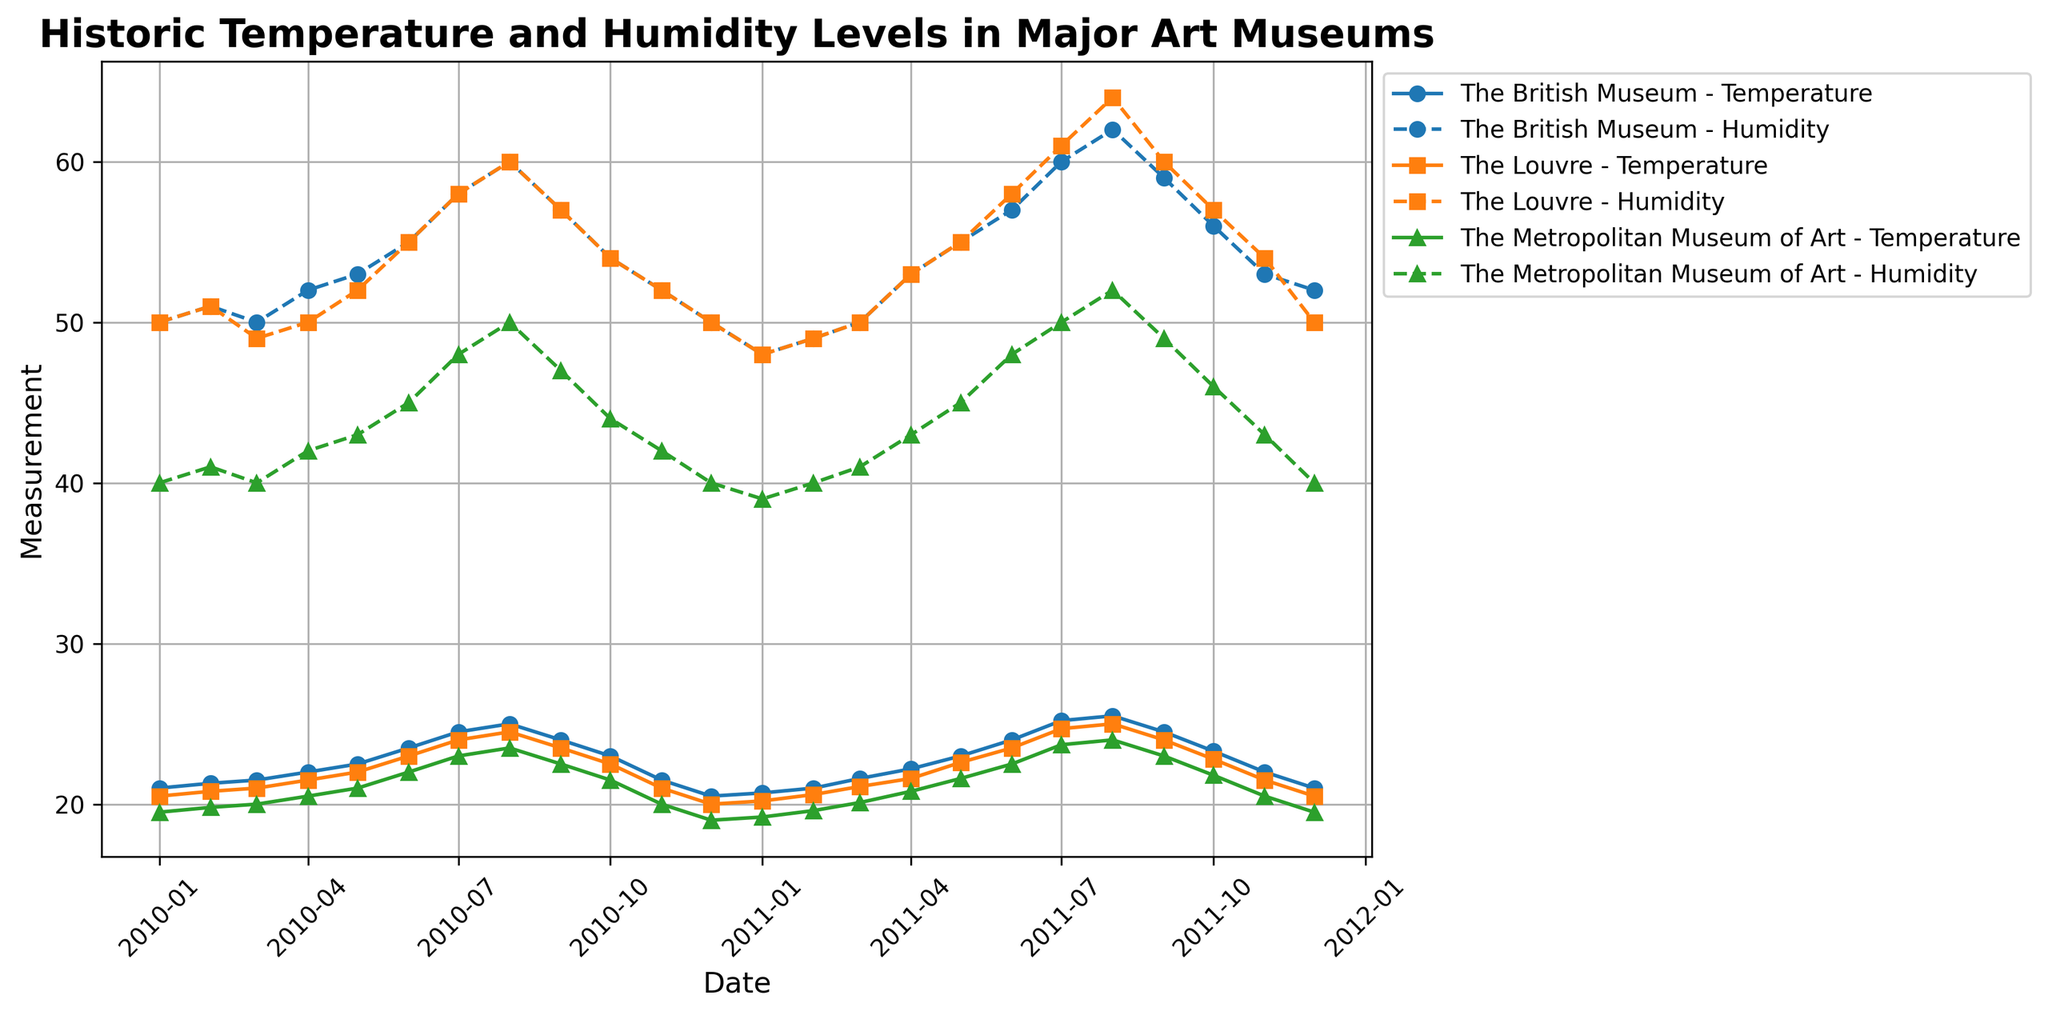Which month in 2011 had the highest humidity level at The Louvre? To find the month with the highest humidity level, examine the humidity line for The Louvre in 2011. Look for the peak value. According to the chart, August has the highest humidity level around 64%.
Answer: August Which museum had the lower average temperature in 2010? To determine the museum with the lower average temperature in 2010, compare the temperature lines for each museum. Calculate the average temperature for each museum and compare them. The Metropolitan Museum of Art has a consistently lower temperature compared to The Louvre and The British Museum in 2010.
Answer: The Metropolitan Museum of Art During which months are the temperature differences between The British Museum and The Metropolitan Museum of Art the greatest? Examine the temperature lines for The British Museum and The Metropolitan Museum of Art and look for the months where the difference in their temperatures is the most prominent. It appears the biggest temperature differences are in July and August.
Answer: July and August What is the average humidity level for The British Museum in 2010? Add up the humidity values for each month of 2010 for The British Museum and divide by the number of months (12) to get the average. Sum: (50+51+50+52+53+55+58+60+57+54+52+50) = 642, Dividing by 12 gives approximately: 642/12 = 53.5
Answer: 53.5 How does the temperature trend compare between The Louvre and The British Museum over the years? To compare the trends, look at the general direction of the temperature lines for both museums. Both show an upward trend from January to August, peaking in the summer, and then declining again towards December. The patterns are quite similar in terms of trends.
Answer: Similar upward summer trend, then decline During which month in 2011 did The Louvre have equal temperature and humidity levels? Identify the points where the lines for temperature and humidity for The Louvre intersect in 2011. This happens in several months throughout the series, particularly in the winter months. The period where they intersect most notably is January.
Answer: January Which museum saw the most change in temperature between July 2010 and July 2011? To determine the greatest temperature change, compare the July 2010 and July 2011 temperatures for each museum. The Metropolitan Museum of Art saw an increase from 23.0 °C in July 2010 to 23.7 °C in July 2011 (0.7 °C change) which is less compared to The Louvre and The British Museum, which saw changes of approximately 0.7 and 0.7 respectively. All had comparable changes around 0.7 °C.
Answer: Comparable change (around 0.7 °C) What is the humidity difference between The Louvre and The Metropolitan Museum of Art in August 2011? Identify the humidity values for The Louvre (64%) and The Metropolitan Museum of Art (52%) in August 2011 and subtract the latter from the former. 64% - 52% = 12%
Answer: 12% 